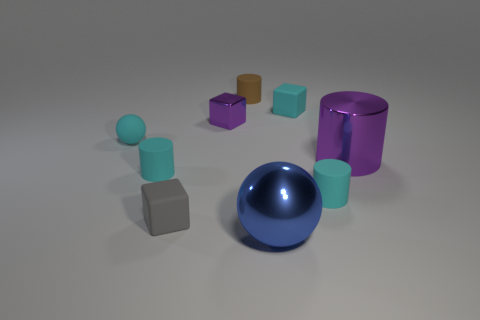Which objects in the image have a metallic texture? The large blue object in the center and the small purple object to its right have metallic textures. 